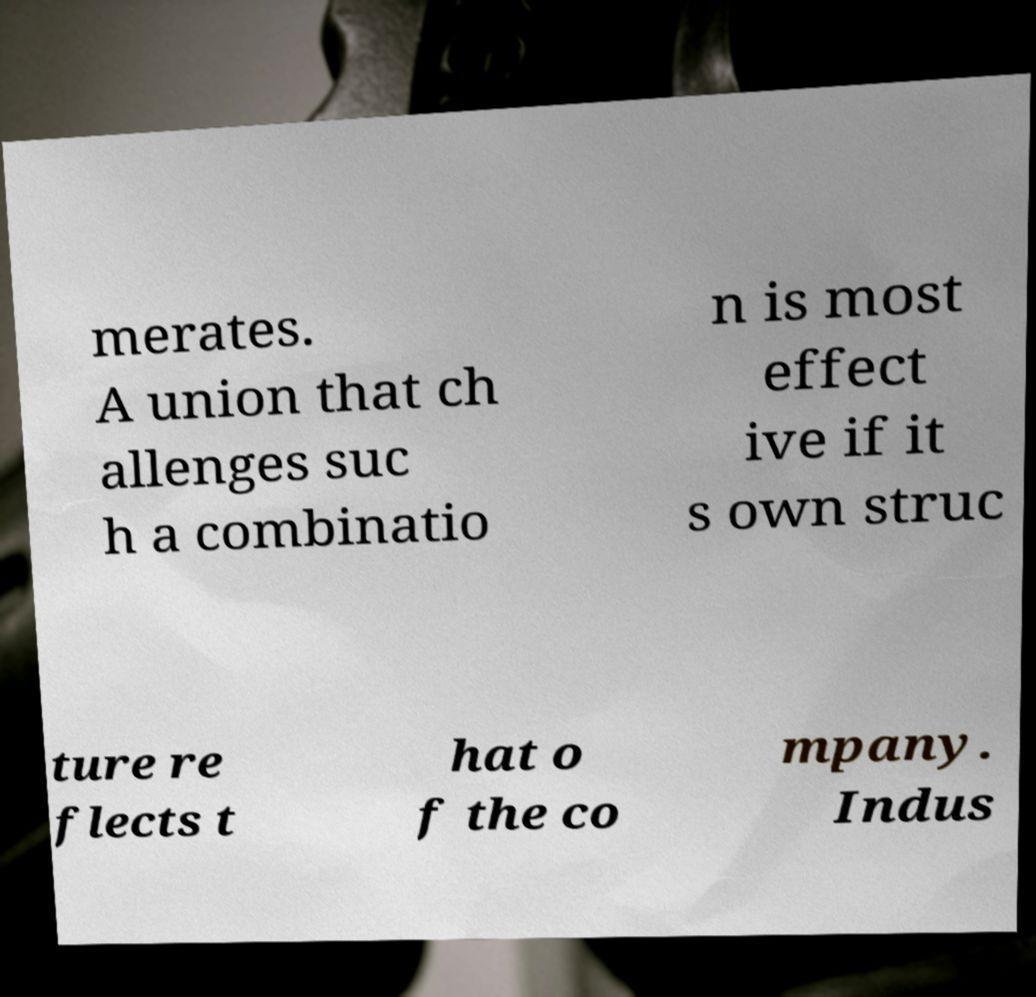Please read and relay the text visible in this image. What does it say? merates. A union that ch allenges suc h a combinatio n is most effect ive if it s own struc ture re flects t hat o f the co mpany. Indus 